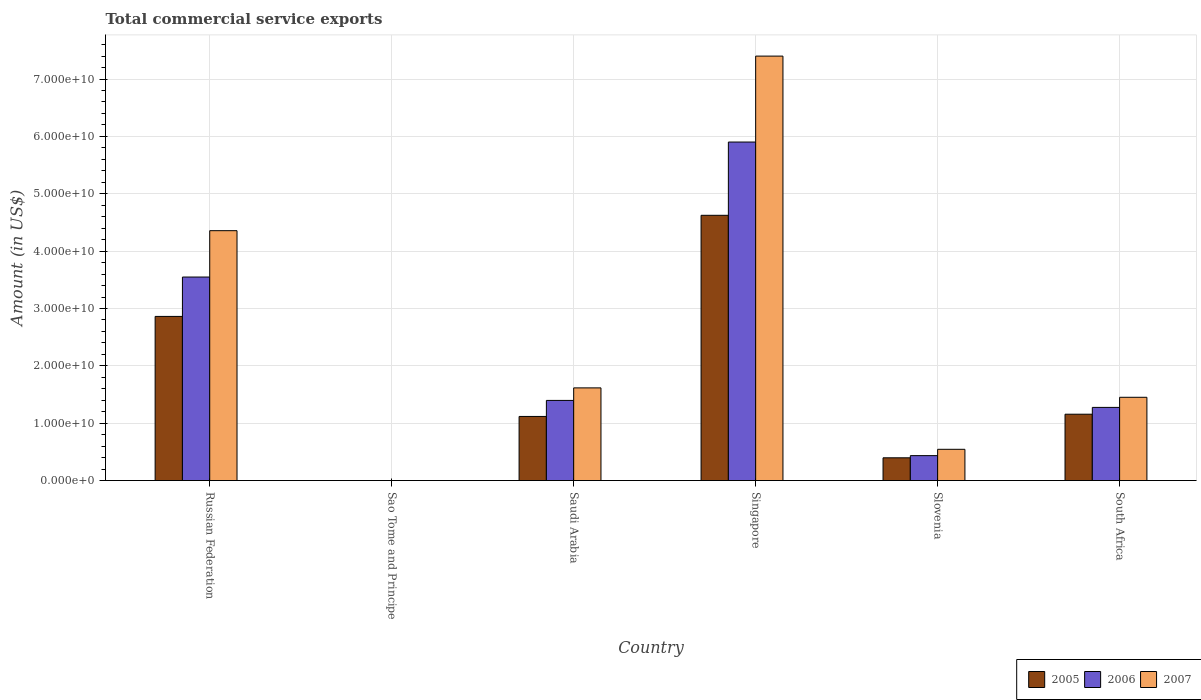How many different coloured bars are there?
Offer a terse response. 3. How many bars are there on the 1st tick from the left?
Keep it short and to the point. 3. How many bars are there on the 6th tick from the right?
Offer a terse response. 3. What is the label of the 4th group of bars from the left?
Your answer should be compact. Singapore. What is the total commercial service exports in 2007 in Slovenia?
Ensure brevity in your answer.  5.45e+09. Across all countries, what is the maximum total commercial service exports in 2007?
Make the answer very short. 7.40e+1. Across all countries, what is the minimum total commercial service exports in 2007?
Your response must be concise. 6.43e+06. In which country was the total commercial service exports in 2006 maximum?
Ensure brevity in your answer.  Singapore. In which country was the total commercial service exports in 2005 minimum?
Keep it short and to the point. Sao Tome and Principe. What is the total total commercial service exports in 2005 in the graph?
Provide a succinct answer. 1.02e+11. What is the difference between the total commercial service exports in 2005 in Russian Federation and that in Saudi Arabia?
Keep it short and to the point. 1.74e+1. What is the difference between the total commercial service exports in 2007 in Russian Federation and the total commercial service exports in 2005 in Saudi Arabia?
Give a very brief answer. 3.24e+1. What is the average total commercial service exports in 2007 per country?
Provide a short and direct response. 2.56e+1. What is the difference between the total commercial service exports of/in 2007 and total commercial service exports of/in 2005 in Russian Federation?
Your answer should be compact. 1.49e+1. In how many countries, is the total commercial service exports in 2007 greater than 68000000000 US$?
Offer a very short reply. 1. What is the ratio of the total commercial service exports in 2005 in Russian Federation to that in Sao Tome and Principe?
Your answer should be very brief. 3229.6. Is the difference between the total commercial service exports in 2007 in Singapore and South Africa greater than the difference between the total commercial service exports in 2005 in Singapore and South Africa?
Provide a short and direct response. Yes. What is the difference between the highest and the second highest total commercial service exports in 2005?
Keep it short and to the point. -1.76e+1. What is the difference between the highest and the lowest total commercial service exports in 2005?
Your answer should be very brief. 4.62e+1. Is the sum of the total commercial service exports in 2006 in Slovenia and South Africa greater than the maximum total commercial service exports in 2005 across all countries?
Your response must be concise. No. What does the 3rd bar from the left in Sao Tome and Principe represents?
Provide a short and direct response. 2007. What does the 2nd bar from the right in Slovenia represents?
Offer a terse response. 2006. Is it the case that in every country, the sum of the total commercial service exports in 2007 and total commercial service exports in 2006 is greater than the total commercial service exports in 2005?
Give a very brief answer. Yes. Are all the bars in the graph horizontal?
Ensure brevity in your answer.  No. How many countries are there in the graph?
Your response must be concise. 6. Does the graph contain any zero values?
Your response must be concise. No. What is the title of the graph?
Give a very brief answer. Total commercial service exports. Does "2006" appear as one of the legend labels in the graph?
Make the answer very short. Yes. What is the Amount (in US$) in 2005 in Russian Federation?
Offer a very short reply. 2.86e+1. What is the Amount (in US$) in 2006 in Russian Federation?
Your response must be concise. 3.55e+1. What is the Amount (in US$) in 2007 in Russian Federation?
Offer a terse response. 4.36e+1. What is the Amount (in US$) of 2005 in Sao Tome and Principe?
Your response must be concise. 8.86e+06. What is the Amount (in US$) of 2006 in Sao Tome and Principe?
Give a very brief answer. 8.14e+06. What is the Amount (in US$) in 2007 in Sao Tome and Principe?
Make the answer very short. 6.43e+06. What is the Amount (in US$) of 2005 in Saudi Arabia?
Make the answer very short. 1.12e+1. What is the Amount (in US$) in 2006 in Saudi Arabia?
Give a very brief answer. 1.40e+1. What is the Amount (in US$) in 2007 in Saudi Arabia?
Your answer should be very brief. 1.62e+1. What is the Amount (in US$) in 2005 in Singapore?
Your answer should be very brief. 4.62e+1. What is the Amount (in US$) of 2006 in Singapore?
Your response must be concise. 5.90e+1. What is the Amount (in US$) of 2007 in Singapore?
Your response must be concise. 7.40e+1. What is the Amount (in US$) in 2005 in Slovenia?
Ensure brevity in your answer.  3.97e+09. What is the Amount (in US$) in 2006 in Slovenia?
Your answer should be compact. 4.35e+09. What is the Amount (in US$) in 2007 in Slovenia?
Provide a short and direct response. 5.45e+09. What is the Amount (in US$) in 2005 in South Africa?
Keep it short and to the point. 1.16e+1. What is the Amount (in US$) of 2006 in South Africa?
Your answer should be compact. 1.28e+1. What is the Amount (in US$) of 2007 in South Africa?
Keep it short and to the point. 1.45e+1. Across all countries, what is the maximum Amount (in US$) in 2005?
Offer a terse response. 4.62e+1. Across all countries, what is the maximum Amount (in US$) in 2006?
Your response must be concise. 5.90e+1. Across all countries, what is the maximum Amount (in US$) in 2007?
Your answer should be compact. 7.40e+1. Across all countries, what is the minimum Amount (in US$) of 2005?
Keep it short and to the point. 8.86e+06. Across all countries, what is the minimum Amount (in US$) in 2006?
Make the answer very short. 8.14e+06. Across all countries, what is the minimum Amount (in US$) of 2007?
Provide a short and direct response. 6.43e+06. What is the total Amount (in US$) of 2005 in the graph?
Provide a short and direct response. 1.02e+11. What is the total Amount (in US$) in 2006 in the graph?
Provide a short and direct response. 1.26e+11. What is the total Amount (in US$) in 2007 in the graph?
Ensure brevity in your answer.  1.54e+11. What is the difference between the Amount (in US$) of 2005 in Russian Federation and that in Sao Tome and Principe?
Your answer should be very brief. 2.86e+1. What is the difference between the Amount (in US$) in 2006 in Russian Federation and that in Sao Tome and Principe?
Provide a succinct answer. 3.55e+1. What is the difference between the Amount (in US$) in 2007 in Russian Federation and that in Sao Tome and Principe?
Offer a very short reply. 4.36e+1. What is the difference between the Amount (in US$) in 2005 in Russian Federation and that in Saudi Arabia?
Provide a succinct answer. 1.74e+1. What is the difference between the Amount (in US$) of 2006 in Russian Federation and that in Saudi Arabia?
Offer a terse response. 2.15e+1. What is the difference between the Amount (in US$) in 2007 in Russian Federation and that in Saudi Arabia?
Your answer should be very brief. 2.74e+1. What is the difference between the Amount (in US$) of 2005 in Russian Federation and that in Singapore?
Give a very brief answer. -1.76e+1. What is the difference between the Amount (in US$) of 2006 in Russian Federation and that in Singapore?
Your response must be concise. -2.35e+1. What is the difference between the Amount (in US$) in 2007 in Russian Federation and that in Singapore?
Provide a short and direct response. -3.04e+1. What is the difference between the Amount (in US$) in 2005 in Russian Federation and that in Slovenia?
Make the answer very short. 2.46e+1. What is the difference between the Amount (in US$) in 2006 in Russian Federation and that in Slovenia?
Make the answer very short. 3.11e+1. What is the difference between the Amount (in US$) in 2007 in Russian Federation and that in Slovenia?
Make the answer very short. 3.81e+1. What is the difference between the Amount (in US$) in 2005 in Russian Federation and that in South Africa?
Keep it short and to the point. 1.70e+1. What is the difference between the Amount (in US$) in 2006 in Russian Federation and that in South Africa?
Your answer should be very brief. 2.27e+1. What is the difference between the Amount (in US$) in 2007 in Russian Federation and that in South Africa?
Make the answer very short. 2.90e+1. What is the difference between the Amount (in US$) in 2005 in Sao Tome and Principe and that in Saudi Arabia?
Offer a terse response. -1.12e+1. What is the difference between the Amount (in US$) of 2006 in Sao Tome and Principe and that in Saudi Arabia?
Your answer should be very brief. -1.40e+1. What is the difference between the Amount (in US$) in 2007 in Sao Tome and Principe and that in Saudi Arabia?
Make the answer very short. -1.62e+1. What is the difference between the Amount (in US$) of 2005 in Sao Tome and Principe and that in Singapore?
Ensure brevity in your answer.  -4.62e+1. What is the difference between the Amount (in US$) in 2006 in Sao Tome and Principe and that in Singapore?
Offer a very short reply. -5.90e+1. What is the difference between the Amount (in US$) in 2007 in Sao Tome and Principe and that in Singapore?
Provide a succinct answer. -7.40e+1. What is the difference between the Amount (in US$) of 2005 in Sao Tome and Principe and that in Slovenia?
Make the answer very short. -3.96e+09. What is the difference between the Amount (in US$) in 2006 in Sao Tome and Principe and that in Slovenia?
Your answer should be very brief. -4.34e+09. What is the difference between the Amount (in US$) in 2007 in Sao Tome and Principe and that in Slovenia?
Offer a very short reply. -5.44e+09. What is the difference between the Amount (in US$) in 2005 in Sao Tome and Principe and that in South Africa?
Offer a terse response. -1.16e+1. What is the difference between the Amount (in US$) of 2006 in Sao Tome and Principe and that in South Africa?
Offer a terse response. -1.27e+1. What is the difference between the Amount (in US$) of 2007 in Sao Tome and Principe and that in South Africa?
Make the answer very short. -1.45e+1. What is the difference between the Amount (in US$) of 2005 in Saudi Arabia and that in Singapore?
Ensure brevity in your answer.  -3.51e+1. What is the difference between the Amount (in US$) in 2006 in Saudi Arabia and that in Singapore?
Provide a succinct answer. -4.50e+1. What is the difference between the Amount (in US$) in 2007 in Saudi Arabia and that in Singapore?
Offer a terse response. -5.78e+1. What is the difference between the Amount (in US$) of 2005 in Saudi Arabia and that in Slovenia?
Keep it short and to the point. 7.21e+09. What is the difference between the Amount (in US$) of 2006 in Saudi Arabia and that in Slovenia?
Your response must be concise. 9.62e+09. What is the difference between the Amount (in US$) in 2007 in Saudi Arabia and that in Slovenia?
Provide a short and direct response. 1.07e+1. What is the difference between the Amount (in US$) in 2005 in Saudi Arabia and that in South Africa?
Offer a terse response. -3.91e+08. What is the difference between the Amount (in US$) of 2006 in Saudi Arabia and that in South Africa?
Offer a very short reply. 1.22e+09. What is the difference between the Amount (in US$) of 2007 in Saudi Arabia and that in South Africa?
Your answer should be compact. 1.64e+09. What is the difference between the Amount (in US$) of 2005 in Singapore and that in Slovenia?
Give a very brief answer. 4.23e+1. What is the difference between the Amount (in US$) of 2006 in Singapore and that in Slovenia?
Make the answer very short. 5.47e+1. What is the difference between the Amount (in US$) of 2007 in Singapore and that in Slovenia?
Your response must be concise. 6.85e+1. What is the difference between the Amount (in US$) in 2005 in Singapore and that in South Africa?
Offer a terse response. 3.47e+1. What is the difference between the Amount (in US$) in 2006 in Singapore and that in South Africa?
Ensure brevity in your answer.  4.63e+1. What is the difference between the Amount (in US$) in 2007 in Singapore and that in South Africa?
Provide a succinct answer. 5.95e+1. What is the difference between the Amount (in US$) in 2005 in Slovenia and that in South Africa?
Offer a terse response. -7.60e+09. What is the difference between the Amount (in US$) in 2006 in Slovenia and that in South Africa?
Ensure brevity in your answer.  -8.41e+09. What is the difference between the Amount (in US$) in 2007 in Slovenia and that in South Africa?
Provide a short and direct response. -9.07e+09. What is the difference between the Amount (in US$) of 2005 in Russian Federation and the Amount (in US$) of 2006 in Sao Tome and Principe?
Your answer should be very brief. 2.86e+1. What is the difference between the Amount (in US$) in 2005 in Russian Federation and the Amount (in US$) in 2007 in Sao Tome and Principe?
Provide a succinct answer. 2.86e+1. What is the difference between the Amount (in US$) of 2006 in Russian Federation and the Amount (in US$) of 2007 in Sao Tome and Principe?
Ensure brevity in your answer.  3.55e+1. What is the difference between the Amount (in US$) of 2005 in Russian Federation and the Amount (in US$) of 2006 in Saudi Arabia?
Ensure brevity in your answer.  1.46e+1. What is the difference between the Amount (in US$) in 2005 in Russian Federation and the Amount (in US$) in 2007 in Saudi Arabia?
Offer a terse response. 1.25e+1. What is the difference between the Amount (in US$) of 2006 in Russian Federation and the Amount (in US$) of 2007 in Saudi Arabia?
Make the answer very short. 1.93e+1. What is the difference between the Amount (in US$) of 2005 in Russian Federation and the Amount (in US$) of 2006 in Singapore?
Keep it short and to the point. -3.04e+1. What is the difference between the Amount (in US$) of 2005 in Russian Federation and the Amount (in US$) of 2007 in Singapore?
Keep it short and to the point. -4.54e+1. What is the difference between the Amount (in US$) in 2006 in Russian Federation and the Amount (in US$) in 2007 in Singapore?
Keep it short and to the point. -3.85e+1. What is the difference between the Amount (in US$) of 2005 in Russian Federation and the Amount (in US$) of 2006 in Slovenia?
Make the answer very short. 2.43e+1. What is the difference between the Amount (in US$) in 2005 in Russian Federation and the Amount (in US$) in 2007 in Slovenia?
Offer a terse response. 2.32e+1. What is the difference between the Amount (in US$) in 2006 in Russian Federation and the Amount (in US$) in 2007 in Slovenia?
Your answer should be very brief. 3.00e+1. What is the difference between the Amount (in US$) of 2005 in Russian Federation and the Amount (in US$) of 2006 in South Africa?
Give a very brief answer. 1.59e+1. What is the difference between the Amount (in US$) in 2005 in Russian Federation and the Amount (in US$) in 2007 in South Africa?
Give a very brief answer. 1.41e+1. What is the difference between the Amount (in US$) in 2006 in Russian Federation and the Amount (in US$) in 2007 in South Africa?
Your answer should be very brief. 2.10e+1. What is the difference between the Amount (in US$) of 2005 in Sao Tome and Principe and the Amount (in US$) of 2006 in Saudi Arabia?
Ensure brevity in your answer.  -1.40e+1. What is the difference between the Amount (in US$) of 2005 in Sao Tome and Principe and the Amount (in US$) of 2007 in Saudi Arabia?
Your answer should be very brief. -1.62e+1. What is the difference between the Amount (in US$) in 2006 in Sao Tome and Principe and the Amount (in US$) in 2007 in Saudi Arabia?
Make the answer very short. -1.62e+1. What is the difference between the Amount (in US$) in 2005 in Sao Tome and Principe and the Amount (in US$) in 2006 in Singapore?
Ensure brevity in your answer.  -5.90e+1. What is the difference between the Amount (in US$) in 2005 in Sao Tome and Principe and the Amount (in US$) in 2007 in Singapore?
Your answer should be compact. -7.40e+1. What is the difference between the Amount (in US$) in 2006 in Sao Tome and Principe and the Amount (in US$) in 2007 in Singapore?
Provide a short and direct response. -7.40e+1. What is the difference between the Amount (in US$) in 2005 in Sao Tome and Principe and the Amount (in US$) in 2006 in Slovenia?
Ensure brevity in your answer.  -4.34e+09. What is the difference between the Amount (in US$) in 2005 in Sao Tome and Principe and the Amount (in US$) in 2007 in Slovenia?
Give a very brief answer. -5.44e+09. What is the difference between the Amount (in US$) of 2006 in Sao Tome and Principe and the Amount (in US$) of 2007 in Slovenia?
Keep it short and to the point. -5.44e+09. What is the difference between the Amount (in US$) in 2005 in Sao Tome and Principe and the Amount (in US$) in 2006 in South Africa?
Keep it short and to the point. -1.27e+1. What is the difference between the Amount (in US$) in 2005 in Sao Tome and Principe and the Amount (in US$) in 2007 in South Africa?
Offer a very short reply. -1.45e+1. What is the difference between the Amount (in US$) in 2006 in Sao Tome and Principe and the Amount (in US$) in 2007 in South Africa?
Your answer should be very brief. -1.45e+1. What is the difference between the Amount (in US$) in 2005 in Saudi Arabia and the Amount (in US$) in 2006 in Singapore?
Your response must be concise. -4.78e+1. What is the difference between the Amount (in US$) in 2005 in Saudi Arabia and the Amount (in US$) in 2007 in Singapore?
Give a very brief answer. -6.28e+1. What is the difference between the Amount (in US$) of 2006 in Saudi Arabia and the Amount (in US$) of 2007 in Singapore?
Your response must be concise. -6.00e+1. What is the difference between the Amount (in US$) in 2005 in Saudi Arabia and the Amount (in US$) in 2006 in Slovenia?
Ensure brevity in your answer.  6.83e+09. What is the difference between the Amount (in US$) in 2005 in Saudi Arabia and the Amount (in US$) in 2007 in Slovenia?
Give a very brief answer. 5.73e+09. What is the difference between the Amount (in US$) in 2006 in Saudi Arabia and the Amount (in US$) in 2007 in Slovenia?
Provide a short and direct response. 8.52e+09. What is the difference between the Amount (in US$) in 2005 in Saudi Arabia and the Amount (in US$) in 2006 in South Africa?
Your answer should be very brief. -1.58e+09. What is the difference between the Amount (in US$) in 2005 in Saudi Arabia and the Amount (in US$) in 2007 in South Africa?
Your answer should be very brief. -3.34e+09. What is the difference between the Amount (in US$) in 2006 in Saudi Arabia and the Amount (in US$) in 2007 in South Africa?
Your answer should be very brief. -5.46e+08. What is the difference between the Amount (in US$) in 2005 in Singapore and the Amount (in US$) in 2006 in Slovenia?
Your answer should be very brief. 4.19e+1. What is the difference between the Amount (in US$) in 2005 in Singapore and the Amount (in US$) in 2007 in Slovenia?
Make the answer very short. 4.08e+1. What is the difference between the Amount (in US$) of 2006 in Singapore and the Amount (in US$) of 2007 in Slovenia?
Make the answer very short. 5.36e+1. What is the difference between the Amount (in US$) in 2005 in Singapore and the Amount (in US$) in 2006 in South Africa?
Keep it short and to the point. 3.35e+1. What is the difference between the Amount (in US$) of 2005 in Singapore and the Amount (in US$) of 2007 in South Africa?
Give a very brief answer. 3.17e+1. What is the difference between the Amount (in US$) in 2006 in Singapore and the Amount (in US$) in 2007 in South Africa?
Your response must be concise. 4.45e+1. What is the difference between the Amount (in US$) in 2005 in Slovenia and the Amount (in US$) in 2006 in South Africa?
Provide a short and direct response. -8.79e+09. What is the difference between the Amount (in US$) of 2005 in Slovenia and the Amount (in US$) of 2007 in South Africa?
Provide a succinct answer. -1.05e+1. What is the difference between the Amount (in US$) of 2006 in Slovenia and the Amount (in US$) of 2007 in South Africa?
Provide a succinct answer. -1.02e+1. What is the average Amount (in US$) in 2005 per country?
Provide a short and direct response. 1.69e+1. What is the average Amount (in US$) of 2006 per country?
Your answer should be very brief. 2.09e+1. What is the average Amount (in US$) of 2007 per country?
Ensure brevity in your answer.  2.56e+1. What is the difference between the Amount (in US$) of 2005 and Amount (in US$) of 2006 in Russian Federation?
Provide a succinct answer. -6.87e+09. What is the difference between the Amount (in US$) of 2005 and Amount (in US$) of 2007 in Russian Federation?
Provide a succinct answer. -1.49e+1. What is the difference between the Amount (in US$) in 2006 and Amount (in US$) in 2007 in Russian Federation?
Give a very brief answer. -8.08e+09. What is the difference between the Amount (in US$) of 2005 and Amount (in US$) of 2006 in Sao Tome and Principe?
Your answer should be very brief. 7.25e+05. What is the difference between the Amount (in US$) of 2005 and Amount (in US$) of 2007 in Sao Tome and Principe?
Provide a succinct answer. 2.43e+06. What is the difference between the Amount (in US$) in 2006 and Amount (in US$) in 2007 in Sao Tome and Principe?
Offer a very short reply. 1.71e+06. What is the difference between the Amount (in US$) in 2005 and Amount (in US$) in 2006 in Saudi Arabia?
Ensure brevity in your answer.  -2.79e+09. What is the difference between the Amount (in US$) in 2005 and Amount (in US$) in 2007 in Saudi Arabia?
Provide a short and direct response. -4.98e+09. What is the difference between the Amount (in US$) in 2006 and Amount (in US$) in 2007 in Saudi Arabia?
Ensure brevity in your answer.  -2.19e+09. What is the difference between the Amount (in US$) of 2005 and Amount (in US$) of 2006 in Singapore?
Give a very brief answer. -1.28e+1. What is the difference between the Amount (in US$) of 2005 and Amount (in US$) of 2007 in Singapore?
Provide a succinct answer. -2.78e+1. What is the difference between the Amount (in US$) of 2006 and Amount (in US$) of 2007 in Singapore?
Ensure brevity in your answer.  -1.50e+1. What is the difference between the Amount (in US$) in 2005 and Amount (in US$) in 2006 in Slovenia?
Provide a succinct answer. -3.80e+08. What is the difference between the Amount (in US$) in 2005 and Amount (in US$) in 2007 in Slovenia?
Your answer should be very brief. -1.48e+09. What is the difference between the Amount (in US$) in 2006 and Amount (in US$) in 2007 in Slovenia?
Provide a succinct answer. -1.10e+09. What is the difference between the Amount (in US$) in 2005 and Amount (in US$) in 2006 in South Africa?
Make the answer very short. -1.19e+09. What is the difference between the Amount (in US$) of 2005 and Amount (in US$) of 2007 in South Africa?
Give a very brief answer. -2.95e+09. What is the difference between the Amount (in US$) of 2006 and Amount (in US$) of 2007 in South Africa?
Your answer should be compact. -1.76e+09. What is the ratio of the Amount (in US$) in 2005 in Russian Federation to that in Sao Tome and Principe?
Keep it short and to the point. 3229.6. What is the ratio of the Amount (in US$) of 2006 in Russian Federation to that in Sao Tome and Principe?
Make the answer very short. 4361.62. What is the ratio of the Amount (in US$) in 2007 in Russian Federation to that in Sao Tome and Principe?
Give a very brief answer. 6776.89. What is the ratio of the Amount (in US$) in 2005 in Russian Federation to that in Saudi Arabia?
Your response must be concise. 2.56. What is the ratio of the Amount (in US$) of 2006 in Russian Federation to that in Saudi Arabia?
Your answer should be very brief. 2.54. What is the ratio of the Amount (in US$) of 2007 in Russian Federation to that in Saudi Arabia?
Offer a terse response. 2.7. What is the ratio of the Amount (in US$) in 2005 in Russian Federation to that in Singapore?
Your response must be concise. 0.62. What is the ratio of the Amount (in US$) in 2006 in Russian Federation to that in Singapore?
Offer a terse response. 0.6. What is the ratio of the Amount (in US$) in 2007 in Russian Federation to that in Singapore?
Ensure brevity in your answer.  0.59. What is the ratio of the Amount (in US$) in 2005 in Russian Federation to that in Slovenia?
Provide a short and direct response. 7.21. What is the ratio of the Amount (in US$) in 2006 in Russian Federation to that in Slovenia?
Offer a terse response. 8.16. What is the ratio of the Amount (in US$) in 2007 in Russian Federation to that in Slovenia?
Your response must be concise. 7.99. What is the ratio of the Amount (in US$) of 2005 in Russian Federation to that in South Africa?
Provide a short and direct response. 2.47. What is the ratio of the Amount (in US$) of 2006 in Russian Federation to that in South Africa?
Provide a succinct answer. 2.78. What is the ratio of the Amount (in US$) in 2007 in Russian Federation to that in South Africa?
Provide a succinct answer. 3. What is the ratio of the Amount (in US$) of 2005 in Sao Tome and Principe to that in Saudi Arabia?
Provide a short and direct response. 0. What is the ratio of the Amount (in US$) in 2006 in Sao Tome and Principe to that in Saudi Arabia?
Give a very brief answer. 0. What is the ratio of the Amount (in US$) in 2007 in Sao Tome and Principe to that in Saudi Arabia?
Provide a short and direct response. 0. What is the ratio of the Amount (in US$) in 2005 in Sao Tome and Principe to that in Singapore?
Offer a very short reply. 0. What is the ratio of the Amount (in US$) of 2007 in Sao Tome and Principe to that in Singapore?
Give a very brief answer. 0. What is the ratio of the Amount (in US$) of 2005 in Sao Tome and Principe to that in Slovenia?
Ensure brevity in your answer.  0. What is the ratio of the Amount (in US$) in 2006 in Sao Tome and Principe to that in Slovenia?
Your response must be concise. 0. What is the ratio of the Amount (in US$) in 2007 in Sao Tome and Principe to that in Slovenia?
Ensure brevity in your answer.  0. What is the ratio of the Amount (in US$) in 2005 in Sao Tome and Principe to that in South Africa?
Offer a very short reply. 0. What is the ratio of the Amount (in US$) of 2006 in Sao Tome and Principe to that in South Africa?
Provide a short and direct response. 0. What is the ratio of the Amount (in US$) of 2005 in Saudi Arabia to that in Singapore?
Your answer should be very brief. 0.24. What is the ratio of the Amount (in US$) of 2006 in Saudi Arabia to that in Singapore?
Your answer should be compact. 0.24. What is the ratio of the Amount (in US$) in 2007 in Saudi Arabia to that in Singapore?
Provide a short and direct response. 0.22. What is the ratio of the Amount (in US$) in 2005 in Saudi Arabia to that in Slovenia?
Keep it short and to the point. 2.82. What is the ratio of the Amount (in US$) of 2006 in Saudi Arabia to that in Slovenia?
Provide a short and direct response. 3.21. What is the ratio of the Amount (in US$) of 2007 in Saudi Arabia to that in Slovenia?
Offer a very short reply. 2.96. What is the ratio of the Amount (in US$) in 2005 in Saudi Arabia to that in South Africa?
Offer a very short reply. 0.97. What is the ratio of the Amount (in US$) in 2006 in Saudi Arabia to that in South Africa?
Ensure brevity in your answer.  1.1. What is the ratio of the Amount (in US$) in 2007 in Saudi Arabia to that in South Africa?
Your response must be concise. 1.11. What is the ratio of the Amount (in US$) in 2005 in Singapore to that in Slovenia?
Offer a terse response. 11.65. What is the ratio of the Amount (in US$) of 2006 in Singapore to that in Slovenia?
Ensure brevity in your answer.  13.57. What is the ratio of the Amount (in US$) in 2007 in Singapore to that in Slovenia?
Make the answer very short. 13.58. What is the ratio of the Amount (in US$) in 2005 in Singapore to that in South Africa?
Your response must be concise. 4. What is the ratio of the Amount (in US$) in 2006 in Singapore to that in South Africa?
Offer a terse response. 4.63. What is the ratio of the Amount (in US$) of 2007 in Singapore to that in South Africa?
Provide a short and direct response. 5.1. What is the ratio of the Amount (in US$) of 2005 in Slovenia to that in South Africa?
Make the answer very short. 0.34. What is the ratio of the Amount (in US$) in 2006 in Slovenia to that in South Africa?
Offer a terse response. 0.34. What is the ratio of the Amount (in US$) in 2007 in Slovenia to that in South Africa?
Make the answer very short. 0.38. What is the difference between the highest and the second highest Amount (in US$) in 2005?
Keep it short and to the point. 1.76e+1. What is the difference between the highest and the second highest Amount (in US$) of 2006?
Your answer should be very brief. 2.35e+1. What is the difference between the highest and the second highest Amount (in US$) in 2007?
Your answer should be very brief. 3.04e+1. What is the difference between the highest and the lowest Amount (in US$) of 2005?
Your answer should be very brief. 4.62e+1. What is the difference between the highest and the lowest Amount (in US$) of 2006?
Provide a succinct answer. 5.90e+1. What is the difference between the highest and the lowest Amount (in US$) in 2007?
Your answer should be very brief. 7.40e+1. 